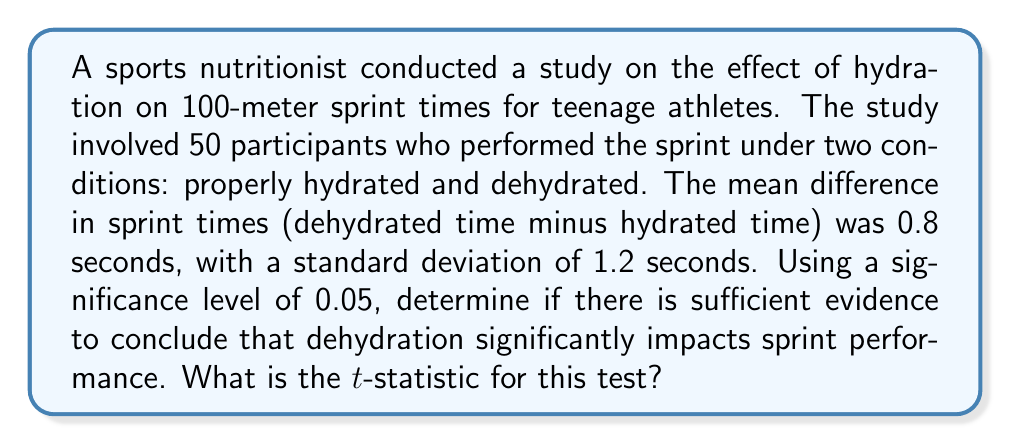Can you answer this question? To determine if dehydration significantly impacts sprint performance, we'll use a paired t-test. Let's follow these steps:

1. State the null and alternative hypotheses:
   $H_0: \mu_d = 0$ (no difference in sprint times)
   $H_a: \mu_d > 0$ (dehydrated times are significantly higher)

2. Calculate the t-statistic using the formula:
   $$t = \frac{\bar{x}_d - \mu_0}{s_d / \sqrt{n}}$$
   
   Where:
   $\bar{x}_d$ = sample mean difference = 0.8 seconds
   $\mu_0$ = hypothesized population mean difference = 0 (under $H_0$)
   $s_d$ = sample standard deviation of differences = 1.2 seconds
   $n$ = sample size = 50

3. Plug in the values:
   $$t = \frac{0.8 - 0}{1.2 / \sqrt{50}}$$

4. Simplify:
   $$t = \frac{0.8}{1.2 / 7.071} = \frac{0.8}{0.170} = 4.706$$

The t-statistic is approximately 4.706.

Note: To complete the hypothesis test, you would compare this t-statistic to the critical value from a t-distribution with 49 degrees of freedom at α = 0.05, or calculate the p-value. Since the t-statistic is positive and large, it suggests that dehydration does significantly impact sprint performance, but the full conclusion would require comparing to the critical value or p-value.
Answer: 4.706 